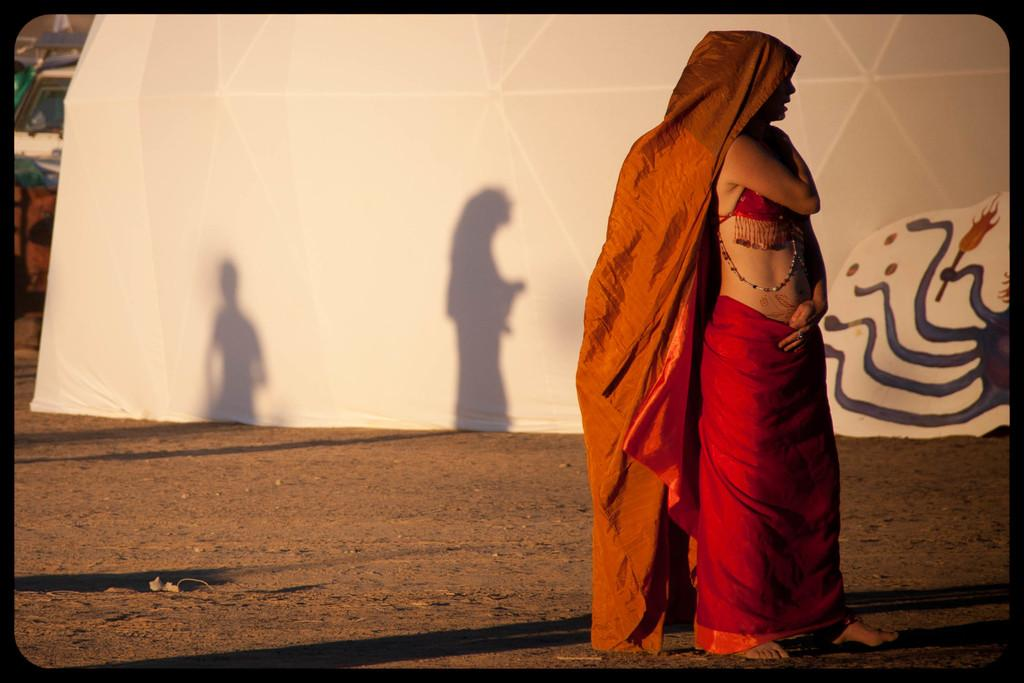What is the main subject of the image? There is a beautiful woman in the image. What is the woman doing in the image? The woman is standing. What is the woman wearing in the image? The woman is wearing a red color dress. What type of trousers is the woman wearing in the image? The woman is not wearing trousers in the image; she is wearing a red color dress. Can you solve the riddle that the woman is holding in the image? There is no riddle present in the image. What is the woman using to hammer nails in the image? There is no hammer or nails present in the image. 